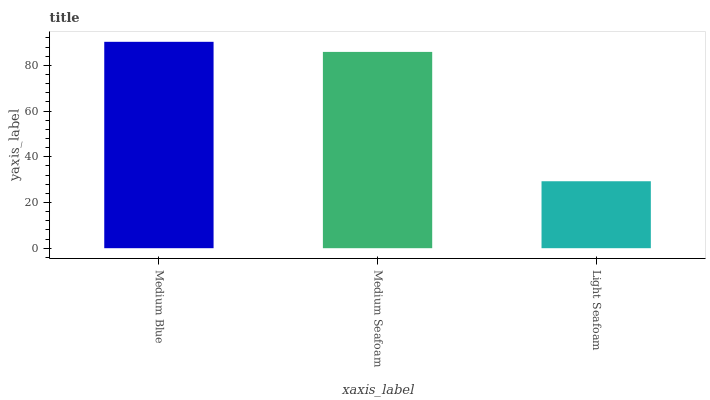Is Light Seafoam the minimum?
Answer yes or no. Yes. Is Medium Blue the maximum?
Answer yes or no. Yes. Is Medium Seafoam the minimum?
Answer yes or no. No. Is Medium Seafoam the maximum?
Answer yes or no. No. Is Medium Blue greater than Medium Seafoam?
Answer yes or no. Yes. Is Medium Seafoam less than Medium Blue?
Answer yes or no. Yes. Is Medium Seafoam greater than Medium Blue?
Answer yes or no. No. Is Medium Blue less than Medium Seafoam?
Answer yes or no. No. Is Medium Seafoam the high median?
Answer yes or no. Yes. Is Medium Seafoam the low median?
Answer yes or no. Yes. Is Medium Blue the high median?
Answer yes or no. No. Is Light Seafoam the low median?
Answer yes or no. No. 